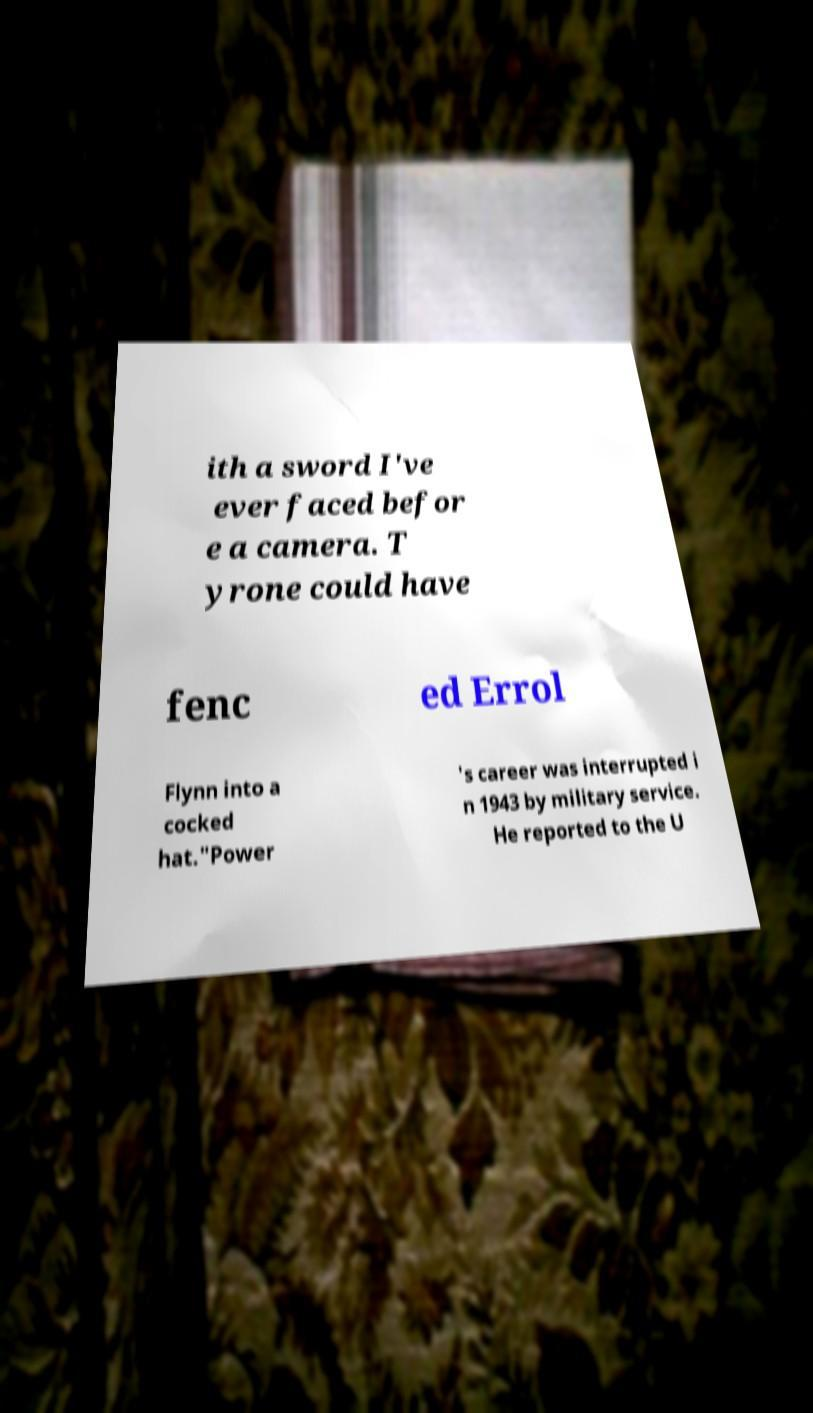Can you read and provide the text displayed in the image?This photo seems to have some interesting text. Can you extract and type it out for me? ith a sword I've ever faced befor e a camera. T yrone could have fenc ed Errol Flynn into a cocked hat."Power 's career was interrupted i n 1943 by military service. He reported to the U 